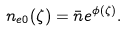Convert formula to latex. <formula><loc_0><loc_0><loc_500><loc_500>n _ { e 0 } ( \zeta ) = { \bar { n } } e ^ { \phi ( \zeta ) } .</formula> 